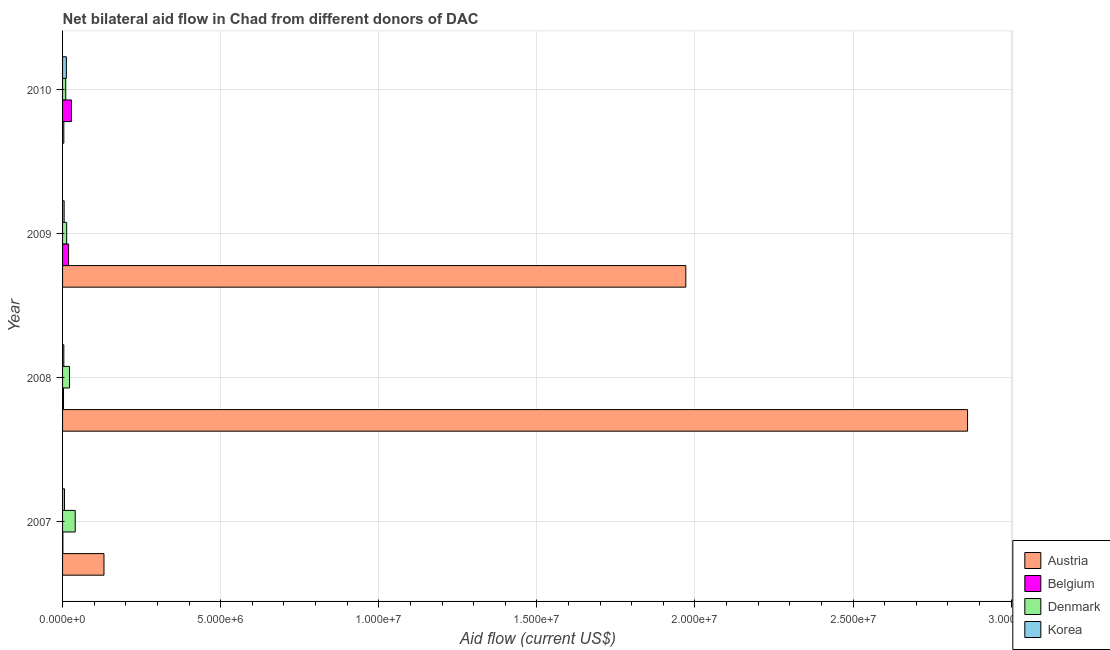Are the number of bars on each tick of the Y-axis equal?
Your answer should be very brief. Yes. How many bars are there on the 4th tick from the bottom?
Provide a succinct answer. 4. In how many cases, is the number of bars for a given year not equal to the number of legend labels?
Your answer should be very brief. 0. What is the amount of aid given by belgium in 2010?
Make the answer very short. 2.80e+05. Across all years, what is the maximum amount of aid given by belgium?
Your answer should be compact. 2.80e+05. Across all years, what is the minimum amount of aid given by denmark?
Your answer should be very brief. 1.00e+05. In which year was the amount of aid given by denmark minimum?
Offer a very short reply. 2010. What is the total amount of aid given by belgium in the graph?
Offer a terse response. 5.10e+05. What is the difference between the amount of aid given by austria in 2007 and that in 2008?
Keep it short and to the point. -2.73e+07. What is the difference between the amount of aid given by belgium in 2007 and the amount of aid given by austria in 2008?
Offer a very short reply. -2.86e+07. What is the average amount of aid given by belgium per year?
Offer a terse response. 1.28e+05. In the year 2007, what is the difference between the amount of aid given by belgium and amount of aid given by austria?
Offer a very short reply. -1.30e+06. What is the ratio of the amount of aid given by austria in 2007 to that in 2010?
Give a very brief answer. 32.75. Is the difference between the amount of aid given by belgium in 2007 and 2010 greater than the difference between the amount of aid given by denmark in 2007 and 2010?
Your answer should be very brief. No. What is the difference between the highest and the second highest amount of aid given by korea?
Make the answer very short. 6.00e+04. What is the difference between the highest and the lowest amount of aid given by austria?
Offer a terse response. 2.86e+07. In how many years, is the amount of aid given by austria greater than the average amount of aid given by austria taken over all years?
Ensure brevity in your answer.  2. What does the 1st bar from the top in 2008 represents?
Make the answer very short. Korea. Is it the case that in every year, the sum of the amount of aid given by austria and amount of aid given by belgium is greater than the amount of aid given by denmark?
Offer a very short reply. Yes. What is the difference between two consecutive major ticks on the X-axis?
Give a very brief answer. 5.00e+06. Does the graph contain grids?
Your answer should be compact. Yes. Where does the legend appear in the graph?
Ensure brevity in your answer.  Bottom right. How many legend labels are there?
Provide a short and direct response. 4. How are the legend labels stacked?
Make the answer very short. Vertical. What is the title of the graph?
Make the answer very short. Net bilateral aid flow in Chad from different donors of DAC. Does "Others" appear as one of the legend labels in the graph?
Ensure brevity in your answer.  No. What is the Aid flow (current US$) of Austria in 2007?
Provide a succinct answer. 1.31e+06. What is the Aid flow (current US$) of Belgium in 2007?
Your answer should be compact. 10000. What is the Aid flow (current US$) of Denmark in 2007?
Ensure brevity in your answer.  4.00e+05. What is the Aid flow (current US$) of Korea in 2007?
Offer a terse response. 6.00e+04. What is the Aid flow (current US$) of Austria in 2008?
Your answer should be compact. 2.86e+07. What is the Aid flow (current US$) of Belgium in 2008?
Give a very brief answer. 3.00e+04. What is the Aid flow (current US$) in Denmark in 2008?
Your response must be concise. 2.20e+05. What is the Aid flow (current US$) in Korea in 2008?
Ensure brevity in your answer.  4.00e+04. What is the Aid flow (current US$) in Austria in 2009?
Make the answer very short. 1.97e+07. What is the Aid flow (current US$) in Belgium in 2009?
Ensure brevity in your answer.  1.90e+05. What is the Aid flow (current US$) in Austria in 2010?
Ensure brevity in your answer.  4.00e+04. Across all years, what is the maximum Aid flow (current US$) of Austria?
Make the answer very short. 2.86e+07. Across all years, what is the maximum Aid flow (current US$) in Denmark?
Your answer should be very brief. 4.00e+05. Across all years, what is the maximum Aid flow (current US$) in Korea?
Give a very brief answer. 1.20e+05. Across all years, what is the minimum Aid flow (current US$) in Korea?
Your answer should be compact. 4.00e+04. What is the total Aid flow (current US$) of Austria in the graph?
Offer a very short reply. 4.97e+07. What is the total Aid flow (current US$) of Belgium in the graph?
Provide a succinct answer. 5.10e+05. What is the total Aid flow (current US$) in Denmark in the graph?
Provide a short and direct response. 8.50e+05. What is the difference between the Aid flow (current US$) in Austria in 2007 and that in 2008?
Your answer should be very brief. -2.73e+07. What is the difference between the Aid flow (current US$) in Austria in 2007 and that in 2009?
Provide a succinct answer. -1.84e+07. What is the difference between the Aid flow (current US$) in Belgium in 2007 and that in 2009?
Ensure brevity in your answer.  -1.80e+05. What is the difference between the Aid flow (current US$) of Austria in 2007 and that in 2010?
Your response must be concise. 1.27e+06. What is the difference between the Aid flow (current US$) of Austria in 2008 and that in 2009?
Your answer should be very brief. 8.91e+06. What is the difference between the Aid flow (current US$) in Belgium in 2008 and that in 2009?
Ensure brevity in your answer.  -1.60e+05. What is the difference between the Aid flow (current US$) in Austria in 2008 and that in 2010?
Offer a terse response. 2.86e+07. What is the difference between the Aid flow (current US$) in Belgium in 2008 and that in 2010?
Provide a short and direct response. -2.50e+05. What is the difference between the Aid flow (current US$) of Austria in 2009 and that in 2010?
Your response must be concise. 1.97e+07. What is the difference between the Aid flow (current US$) of Austria in 2007 and the Aid flow (current US$) of Belgium in 2008?
Offer a terse response. 1.28e+06. What is the difference between the Aid flow (current US$) in Austria in 2007 and the Aid flow (current US$) in Denmark in 2008?
Your answer should be compact. 1.09e+06. What is the difference between the Aid flow (current US$) in Austria in 2007 and the Aid flow (current US$) in Korea in 2008?
Provide a short and direct response. 1.27e+06. What is the difference between the Aid flow (current US$) of Belgium in 2007 and the Aid flow (current US$) of Denmark in 2008?
Give a very brief answer. -2.10e+05. What is the difference between the Aid flow (current US$) of Austria in 2007 and the Aid flow (current US$) of Belgium in 2009?
Ensure brevity in your answer.  1.12e+06. What is the difference between the Aid flow (current US$) in Austria in 2007 and the Aid flow (current US$) in Denmark in 2009?
Your response must be concise. 1.18e+06. What is the difference between the Aid flow (current US$) of Austria in 2007 and the Aid flow (current US$) of Korea in 2009?
Offer a terse response. 1.26e+06. What is the difference between the Aid flow (current US$) of Belgium in 2007 and the Aid flow (current US$) of Korea in 2009?
Provide a succinct answer. -4.00e+04. What is the difference between the Aid flow (current US$) in Austria in 2007 and the Aid flow (current US$) in Belgium in 2010?
Provide a short and direct response. 1.03e+06. What is the difference between the Aid flow (current US$) in Austria in 2007 and the Aid flow (current US$) in Denmark in 2010?
Ensure brevity in your answer.  1.21e+06. What is the difference between the Aid flow (current US$) of Austria in 2007 and the Aid flow (current US$) of Korea in 2010?
Ensure brevity in your answer.  1.19e+06. What is the difference between the Aid flow (current US$) in Austria in 2008 and the Aid flow (current US$) in Belgium in 2009?
Provide a short and direct response. 2.84e+07. What is the difference between the Aid flow (current US$) in Austria in 2008 and the Aid flow (current US$) in Denmark in 2009?
Your response must be concise. 2.85e+07. What is the difference between the Aid flow (current US$) in Austria in 2008 and the Aid flow (current US$) in Korea in 2009?
Ensure brevity in your answer.  2.86e+07. What is the difference between the Aid flow (current US$) in Belgium in 2008 and the Aid flow (current US$) in Denmark in 2009?
Provide a short and direct response. -1.00e+05. What is the difference between the Aid flow (current US$) in Denmark in 2008 and the Aid flow (current US$) in Korea in 2009?
Keep it short and to the point. 1.70e+05. What is the difference between the Aid flow (current US$) of Austria in 2008 and the Aid flow (current US$) of Belgium in 2010?
Offer a terse response. 2.83e+07. What is the difference between the Aid flow (current US$) of Austria in 2008 and the Aid flow (current US$) of Denmark in 2010?
Your answer should be compact. 2.85e+07. What is the difference between the Aid flow (current US$) of Austria in 2008 and the Aid flow (current US$) of Korea in 2010?
Ensure brevity in your answer.  2.85e+07. What is the difference between the Aid flow (current US$) in Austria in 2009 and the Aid flow (current US$) in Belgium in 2010?
Make the answer very short. 1.94e+07. What is the difference between the Aid flow (current US$) of Austria in 2009 and the Aid flow (current US$) of Denmark in 2010?
Your answer should be compact. 1.96e+07. What is the difference between the Aid flow (current US$) of Austria in 2009 and the Aid flow (current US$) of Korea in 2010?
Your answer should be very brief. 1.96e+07. What is the difference between the Aid flow (current US$) of Belgium in 2009 and the Aid flow (current US$) of Korea in 2010?
Provide a short and direct response. 7.00e+04. What is the difference between the Aid flow (current US$) in Denmark in 2009 and the Aid flow (current US$) in Korea in 2010?
Keep it short and to the point. 10000. What is the average Aid flow (current US$) of Austria per year?
Provide a succinct answer. 1.24e+07. What is the average Aid flow (current US$) in Belgium per year?
Offer a very short reply. 1.28e+05. What is the average Aid flow (current US$) of Denmark per year?
Provide a succinct answer. 2.12e+05. What is the average Aid flow (current US$) of Korea per year?
Provide a succinct answer. 6.75e+04. In the year 2007, what is the difference between the Aid flow (current US$) in Austria and Aid flow (current US$) in Belgium?
Keep it short and to the point. 1.30e+06. In the year 2007, what is the difference between the Aid flow (current US$) of Austria and Aid flow (current US$) of Denmark?
Make the answer very short. 9.10e+05. In the year 2007, what is the difference between the Aid flow (current US$) in Austria and Aid flow (current US$) in Korea?
Keep it short and to the point. 1.25e+06. In the year 2007, what is the difference between the Aid flow (current US$) in Belgium and Aid flow (current US$) in Denmark?
Offer a very short reply. -3.90e+05. In the year 2008, what is the difference between the Aid flow (current US$) of Austria and Aid flow (current US$) of Belgium?
Offer a terse response. 2.86e+07. In the year 2008, what is the difference between the Aid flow (current US$) of Austria and Aid flow (current US$) of Denmark?
Your answer should be compact. 2.84e+07. In the year 2008, what is the difference between the Aid flow (current US$) in Austria and Aid flow (current US$) in Korea?
Ensure brevity in your answer.  2.86e+07. In the year 2008, what is the difference between the Aid flow (current US$) in Belgium and Aid flow (current US$) in Denmark?
Offer a terse response. -1.90e+05. In the year 2008, what is the difference between the Aid flow (current US$) in Belgium and Aid flow (current US$) in Korea?
Offer a terse response. -10000. In the year 2009, what is the difference between the Aid flow (current US$) in Austria and Aid flow (current US$) in Belgium?
Give a very brief answer. 1.95e+07. In the year 2009, what is the difference between the Aid flow (current US$) of Austria and Aid flow (current US$) of Denmark?
Give a very brief answer. 1.96e+07. In the year 2009, what is the difference between the Aid flow (current US$) of Austria and Aid flow (current US$) of Korea?
Your answer should be very brief. 1.97e+07. In the year 2009, what is the difference between the Aid flow (current US$) in Belgium and Aid flow (current US$) in Denmark?
Keep it short and to the point. 6.00e+04. In the year 2010, what is the difference between the Aid flow (current US$) in Austria and Aid flow (current US$) in Belgium?
Provide a succinct answer. -2.40e+05. In the year 2010, what is the difference between the Aid flow (current US$) of Austria and Aid flow (current US$) of Korea?
Your answer should be compact. -8.00e+04. In the year 2010, what is the difference between the Aid flow (current US$) in Belgium and Aid flow (current US$) in Korea?
Your answer should be very brief. 1.60e+05. What is the ratio of the Aid flow (current US$) of Austria in 2007 to that in 2008?
Offer a very short reply. 0.05. What is the ratio of the Aid flow (current US$) in Belgium in 2007 to that in 2008?
Your response must be concise. 0.33. What is the ratio of the Aid flow (current US$) of Denmark in 2007 to that in 2008?
Provide a short and direct response. 1.82. What is the ratio of the Aid flow (current US$) of Austria in 2007 to that in 2009?
Make the answer very short. 0.07. What is the ratio of the Aid flow (current US$) of Belgium in 2007 to that in 2009?
Offer a terse response. 0.05. What is the ratio of the Aid flow (current US$) of Denmark in 2007 to that in 2009?
Your answer should be compact. 3.08. What is the ratio of the Aid flow (current US$) in Korea in 2007 to that in 2009?
Make the answer very short. 1.2. What is the ratio of the Aid flow (current US$) in Austria in 2007 to that in 2010?
Offer a very short reply. 32.75. What is the ratio of the Aid flow (current US$) in Belgium in 2007 to that in 2010?
Keep it short and to the point. 0.04. What is the ratio of the Aid flow (current US$) of Denmark in 2007 to that in 2010?
Make the answer very short. 4. What is the ratio of the Aid flow (current US$) in Korea in 2007 to that in 2010?
Offer a terse response. 0.5. What is the ratio of the Aid flow (current US$) of Austria in 2008 to that in 2009?
Provide a short and direct response. 1.45. What is the ratio of the Aid flow (current US$) of Belgium in 2008 to that in 2009?
Offer a very short reply. 0.16. What is the ratio of the Aid flow (current US$) of Denmark in 2008 to that in 2009?
Provide a short and direct response. 1.69. What is the ratio of the Aid flow (current US$) of Austria in 2008 to that in 2010?
Ensure brevity in your answer.  715.5. What is the ratio of the Aid flow (current US$) of Belgium in 2008 to that in 2010?
Ensure brevity in your answer.  0.11. What is the ratio of the Aid flow (current US$) in Denmark in 2008 to that in 2010?
Provide a short and direct response. 2.2. What is the ratio of the Aid flow (current US$) in Korea in 2008 to that in 2010?
Provide a short and direct response. 0.33. What is the ratio of the Aid flow (current US$) of Austria in 2009 to that in 2010?
Make the answer very short. 492.75. What is the ratio of the Aid flow (current US$) of Belgium in 2009 to that in 2010?
Keep it short and to the point. 0.68. What is the ratio of the Aid flow (current US$) in Denmark in 2009 to that in 2010?
Your answer should be very brief. 1.3. What is the ratio of the Aid flow (current US$) of Korea in 2009 to that in 2010?
Your response must be concise. 0.42. What is the difference between the highest and the second highest Aid flow (current US$) of Austria?
Make the answer very short. 8.91e+06. What is the difference between the highest and the second highest Aid flow (current US$) in Belgium?
Provide a short and direct response. 9.00e+04. What is the difference between the highest and the second highest Aid flow (current US$) in Denmark?
Make the answer very short. 1.80e+05. What is the difference between the highest and the lowest Aid flow (current US$) of Austria?
Provide a succinct answer. 2.86e+07. What is the difference between the highest and the lowest Aid flow (current US$) in Korea?
Give a very brief answer. 8.00e+04. 